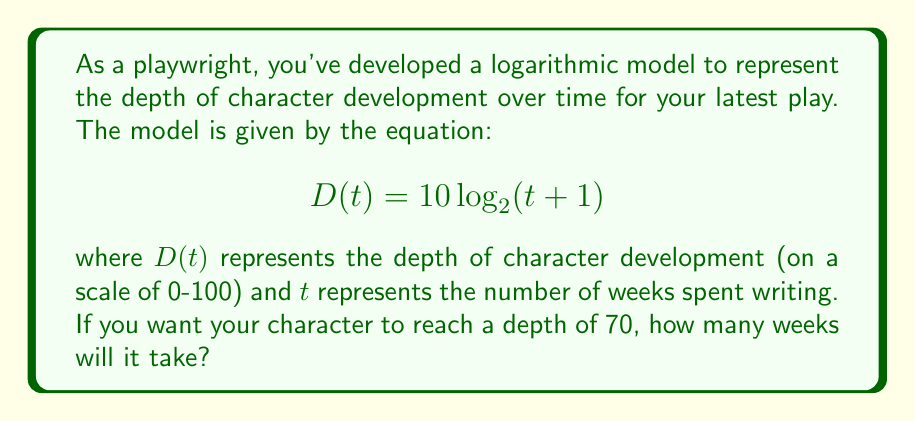Could you help me with this problem? To solve this problem, we need to use the given logarithmic model and solve for $t$ when $D(t) = 70$. Let's approach this step-by-step:

1) We start with the equation:
   $$D(t) = 10 \log_2(t + 1)$$

2) We want to find $t$ when $D(t) = 70$, so we substitute this:
   $$70 = 10 \log_2(t + 1)$$

3) First, let's isolate the logarithm by dividing both sides by 10:
   $$7 = \log_2(t + 1)$$

4) Now, to solve for $t$, we need to apply the inverse function of $\log_2$, which is $2^x$:
   $$2^7 = t + 1$$

5) Calculate $2^7$:
   $$128 = t + 1$$

6) Finally, subtract 1 from both sides to isolate $t$:
   $$127 = t$$

Therefore, it will take 127 weeks for the character to reach a depth of 70 according to this logarithmic model.
Answer: 127 weeks 